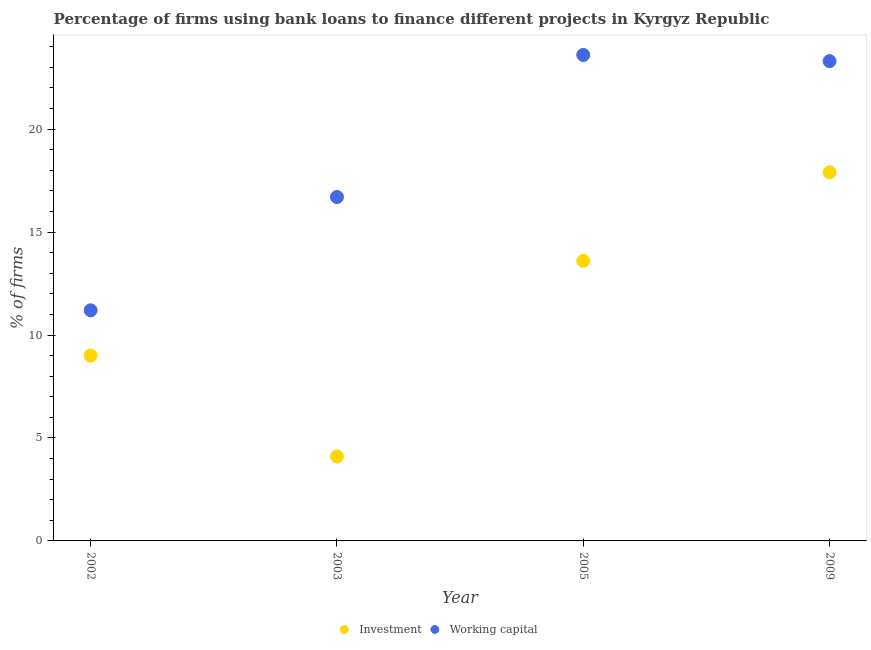What is the percentage of firms using banks to finance working capital in 2005?
Ensure brevity in your answer.  23.6. What is the total percentage of firms using banks to finance working capital in the graph?
Your answer should be very brief. 74.8. What is the difference between the percentage of firms using banks to finance investment in 2002 and that in 2005?
Offer a terse response. -4.6. What is the difference between the percentage of firms using banks to finance working capital in 2002 and the percentage of firms using banks to finance investment in 2009?
Offer a very short reply. -6.7. In the year 2002, what is the difference between the percentage of firms using banks to finance investment and percentage of firms using banks to finance working capital?
Make the answer very short. -2.2. What is the ratio of the percentage of firms using banks to finance investment in 2003 to that in 2005?
Offer a very short reply. 0.3. What is the difference between the highest and the second highest percentage of firms using banks to finance investment?
Offer a very short reply. 4.3. What is the difference between the highest and the lowest percentage of firms using banks to finance investment?
Provide a succinct answer. 13.8. Does the percentage of firms using banks to finance working capital monotonically increase over the years?
Give a very brief answer. No. What is the difference between two consecutive major ticks on the Y-axis?
Provide a succinct answer. 5. Does the graph contain any zero values?
Offer a very short reply. No. Does the graph contain grids?
Your answer should be compact. No. How are the legend labels stacked?
Provide a succinct answer. Horizontal. What is the title of the graph?
Your answer should be compact. Percentage of firms using bank loans to finance different projects in Kyrgyz Republic. What is the label or title of the X-axis?
Keep it short and to the point. Year. What is the label or title of the Y-axis?
Ensure brevity in your answer.  % of firms. What is the % of firms in Working capital in 2002?
Offer a very short reply. 11.2. What is the % of firms of Investment in 2003?
Make the answer very short. 4.1. What is the % of firms of Working capital in 2003?
Offer a terse response. 16.7. What is the % of firms in Working capital in 2005?
Offer a very short reply. 23.6. What is the % of firms in Investment in 2009?
Offer a terse response. 17.9. What is the % of firms in Working capital in 2009?
Give a very brief answer. 23.3. Across all years, what is the maximum % of firms in Investment?
Offer a terse response. 17.9. Across all years, what is the maximum % of firms in Working capital?
Offer a terse response. 23.6. Across all years, what is the minimum % of firms of Investment?
Your answer should be compact. 4.1. Across all years, what is the minimum % of firms of Working capital?
Make the answer very short. 11.2. What is the total % of firms of Investment in the graph?
Provide a succinct answer. 44.6. What is the total % of firms of Working capital in the graph?
Your response must be concise. 74.8. What is the difference between the % of firms in Investment in 2002 and that in 2003?
Offer a terse response. 4.9. What is the difference between the % of firms of Working capital in 2002 and that in 2003?
Make the answer very short. -5.5. What is the difference between the % of firms of Investment in 2002 and that in 2009?
Provide a short and direct response. -8.9. What is the difference between the % of firms of Working capital in 2002 and that in 2009?
Offer a very short reply. -12.1. What is the difference between the % of firms of Working capital in 2003 and that in 2005?
Keep it short and to the point. -6.9. What is the difference between the % of firms of Investment in 2003 and that in 2009?
Ensure brevity in your answer.  -13.8. What is the difference between the % of firms in Investment in 2005 and that in 2009?
Keep it short and to the point. -4.3. What is the difference between the % of firms in Working capital in 2005 and that in 2009?
Keep it short and to the point. 0.3. What is the difference between the % of firms of Investment in 2002 and the % of firms of Working capital in 2003?
Provide a short and direct response. -7.7. What is the difference between the % of firms of Investment in 2002 and the % of firms of Working capital in 2005?
Ensure brevity in your answer.  -14.6. What is the difference between the % of firms in Investment in 2002 and the % of firms in Working capital in 2009?
Your answer should be compact. -14.3. What is the difference between the % of firms of Investment in 2003 and the % of firms of Working capital in 2005?
Provide a short and direct response. -19.5. What is the difference between the % of firms in Investment in 2003 and the % of firms in Working capital in 2009?
Provide a succinct answer. -19.2. What is the average % of firms of Investment per year?
Give a very brief answer. 11.15. In the year 2005, what is the difference between the % of firms in Investment and % of firms in Working capital?
Make the answer very short. -10. In the year 2009, what is the difference between the % of firms in Investment and % of firms in Working capital?
Provide a short and direct response. -5.4. What is the ratio of the % of firms in Investment in 2002 to that in 2003?
Make the answer very short. 2.2. What is the ratio of the % of firms of Working capital in 2002 to that in 2003?
Provide a succinct answer. 0.67. What is the ratio of the % of firms of Investment in 2002 to that in 2005?
Provide a succinct answer. 0.66. What is the ratio of the % of firms in Working capital in 2002 to that in 2005?
Keep it short and to the point. 0.47. What is the ratio of the % of firms in Investment in 2002 to that in 2009?
Offer a very short reply. 0.5. What is the ratio of the % of firms in Working capital in 2002 to that in 2009?
Give a very brief answer. 0.48. What is the ratio of the % of firms in Investment in 2003 to that in 2005?
Provide a short and direct response. 0.3. What is the ratio of the % of firms in Working capital in 2003 to that in 2005?
Make the answer very short. 0.71. What is the ratio of the % of firms in Investment in 2003 to that in 2009?
Your answer should be compact. 0.23. What is the ratio of the % of firms in Working capital in 2003 to that in 2009?
Give a very brief answer. 0.72. What is the ratio of the % of firms in Investment in 2005 to that in 2009?
Provide a short and direct response. 0.76. What is the ratio of the % of firms of Working capital in 2005 to that in 2009?
Your answer should be compact. 1.01. What is the difference between the highest and the lowest % of firms in Investment?
Provide a short and direct response. 13.8. 